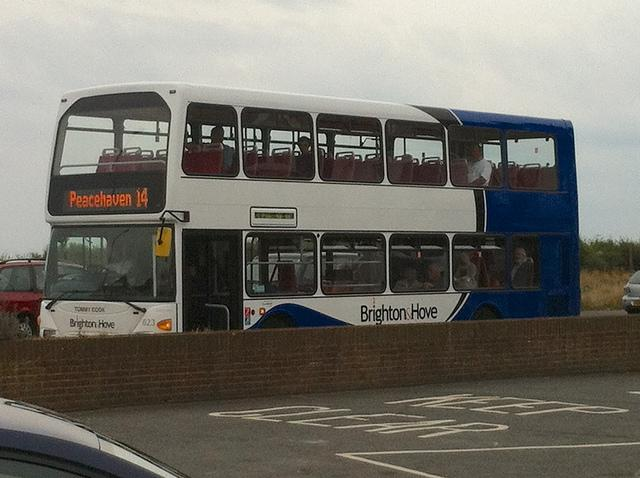In which country's streets does this bus travel? Please explain your reasoning. briton. A double decker bus is driving in the street. 